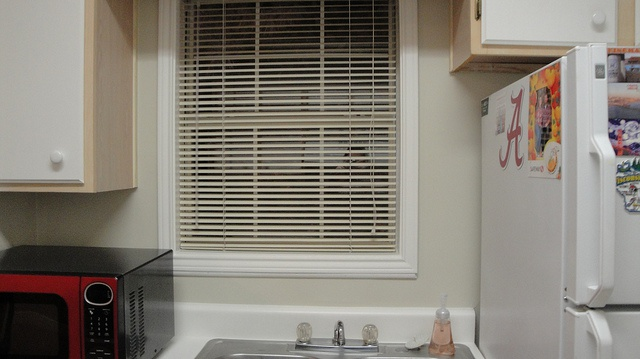Describe the objects in this image and their specific colors. I can see refrigerator in darkgray, lightgray, and gray tones, microwave in darkgray, black, gray, and maroon tones, and sink in darkgray and gray tones in this image. 